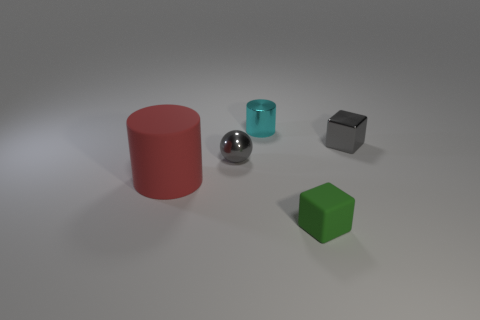How many other metallic things have the same shape as the tiny cyan metallic thing?
Give a very brief answer. 0. How many red things are either small metal things or small metal cylinders?
Provide a succinct answer. 0. How big is the cylinder in front of the metallic thing on the right side of the tiny cyan object?
Provide a short and direct response. Large. What material is the other object that is the same shape as the tiny rubber thing?
Provide a succinct answer. Metal. What number of yellow spheres have the same size as the cyan thing?
Your response must be concise. 0. Does the red matte object have the same size as the shiny cube?
Your response must be concise. No. There is a metallic thing that is in front of the small shiny cylinder and on the left side of the small green thing; how big is it?
Your answer should be compact. Small. Is the number of large matte cylinders right of the gray shiny sphere greater than the number of small metallic objects on the left side of the large cylinder?
Your answer should be compact. No. There is a small object that is the same shape as the big red rubber thing; what color is it?
Make the answer very short. Cyan. There is a small object that is in front of the big red rubber cylinder; is its color the same as the metallic sphere?
Make the answer very short. No. 